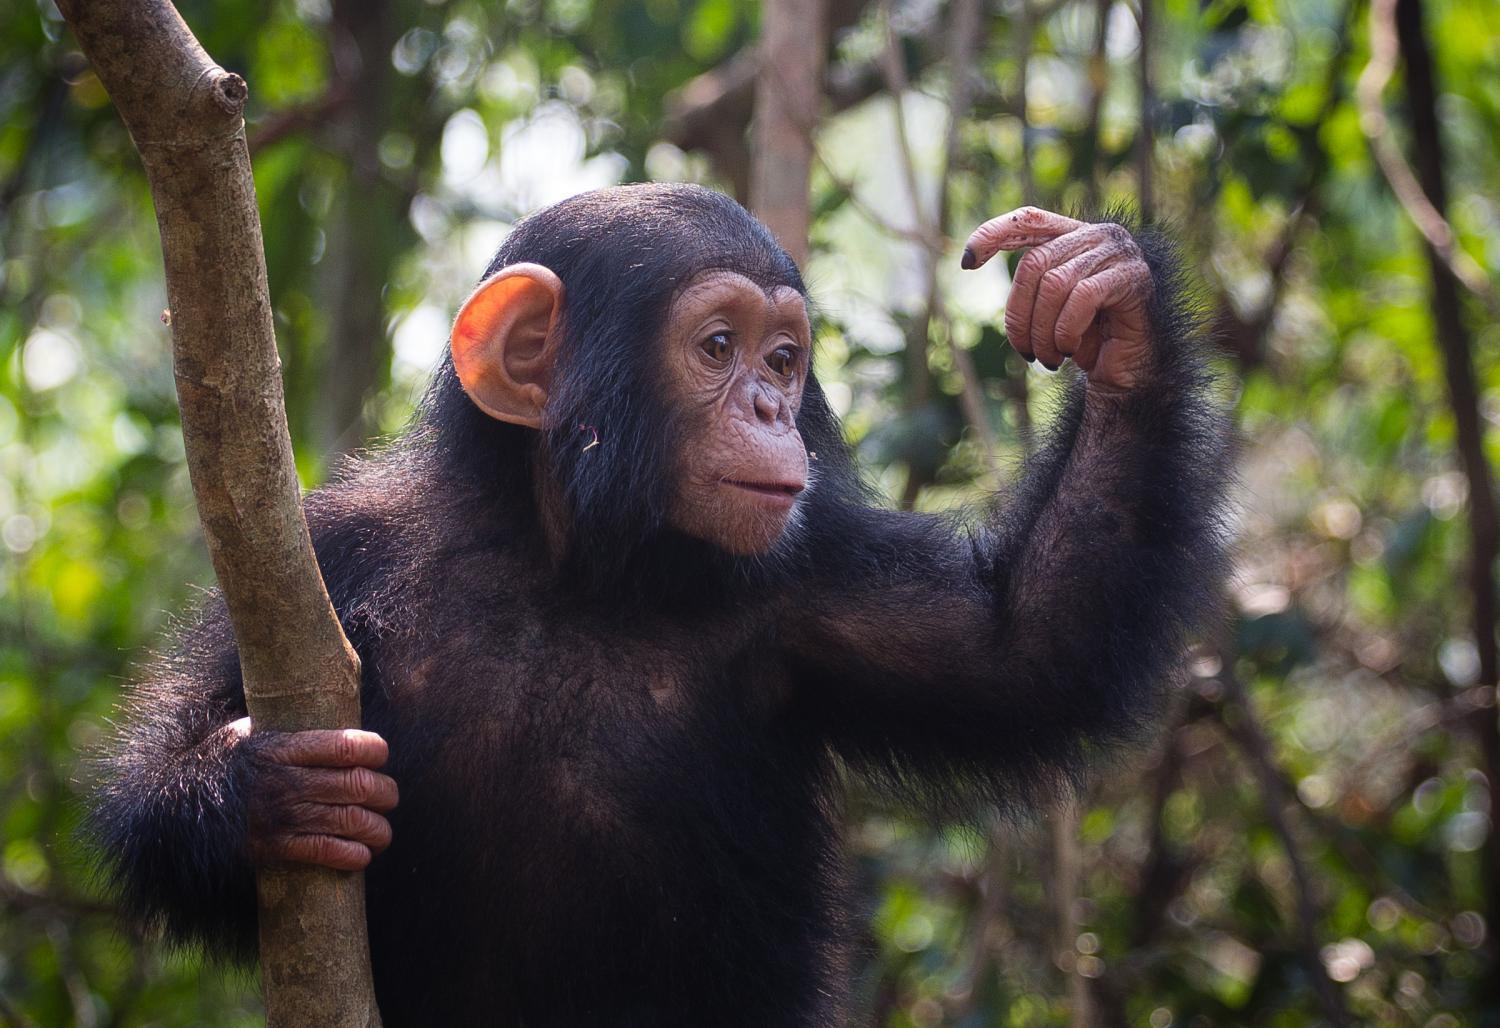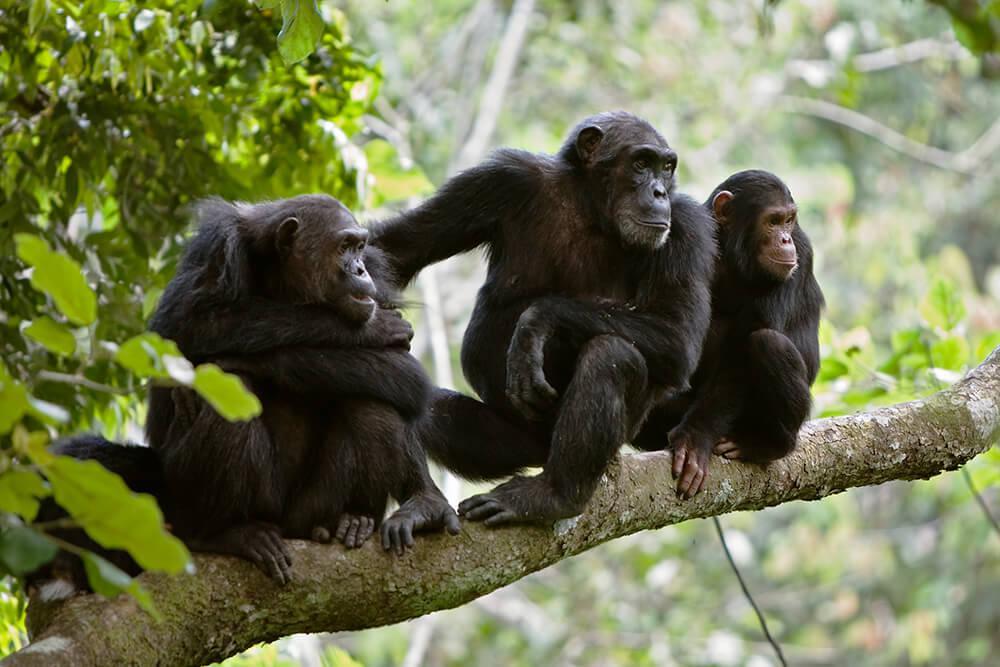The first image is the image on the left, the second image is the image on the right. For the images shown, is this caption "Atleast one image shows exactly two chimps sitting in the grass." true? Answer yes or no. No. The first image is the image on the left, the second image is the image on the right. Evaluate the accuracy of this statement regarding the images: "The image on the left shows a baby monkey clinging on its mother.". Is it true? Answer yes or no. No. 